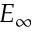Convert formula to latex. <formula><loc_0><loc_0><loc_500><loc_500>E _ { \infty }</formula> 